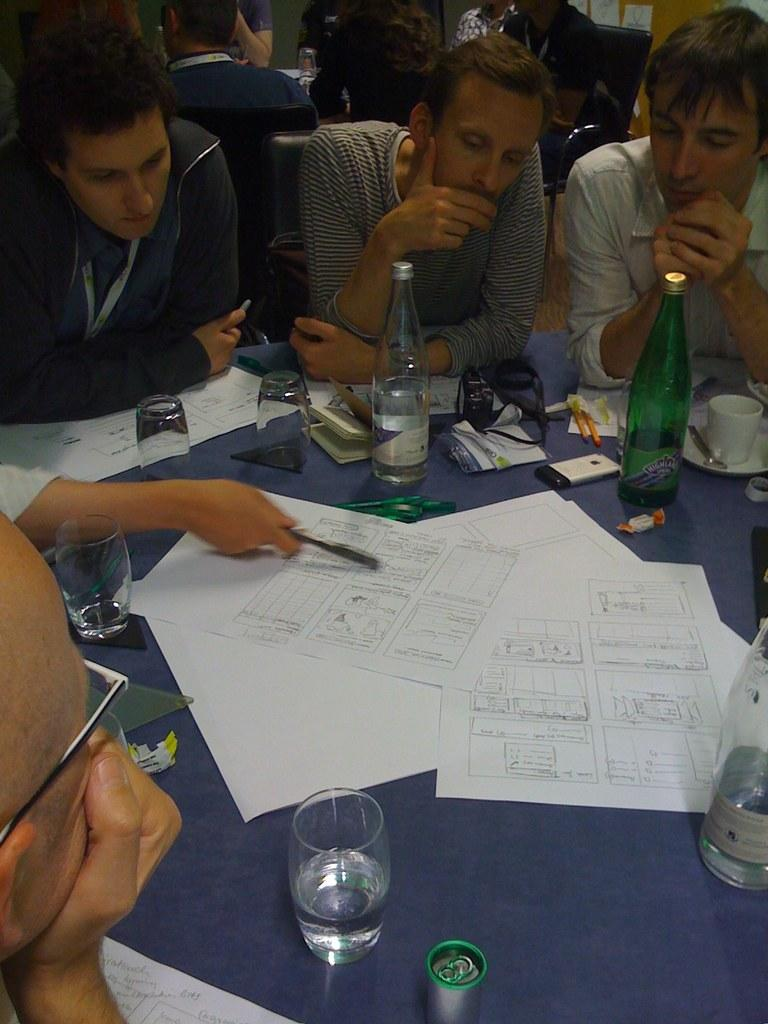How are the people positioned around the table in the image? The people are sitting around a table in chairs. What objects can be seen on the table? Papers, mobiles, bottles, and glasses are placed on the table. Are there any people in the background of the image? Yes, there are some people sitting in the background. What type of noise can be heard coming from the tramp in the image? There is no tramp present in the image, so it is not possible to determine what type of noise might be heard. 